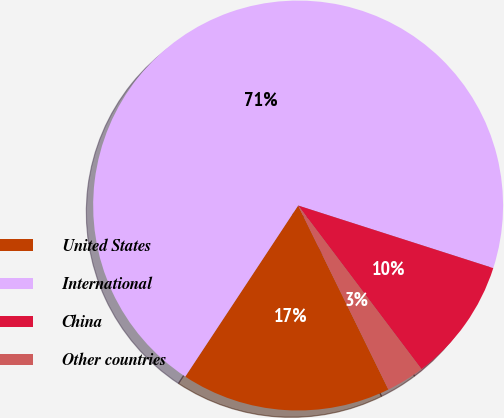Convert chart to OTSL. <chart><loc_0><loc_0><loc_500><loc_500><pie_chart><fcel>United States<fcel>International<fcel>China<fcel>Other countries<nl><fcel>16.54%<fcel>70.66%<fcel>9.78%<fcel>3.02%<nl></chart> 